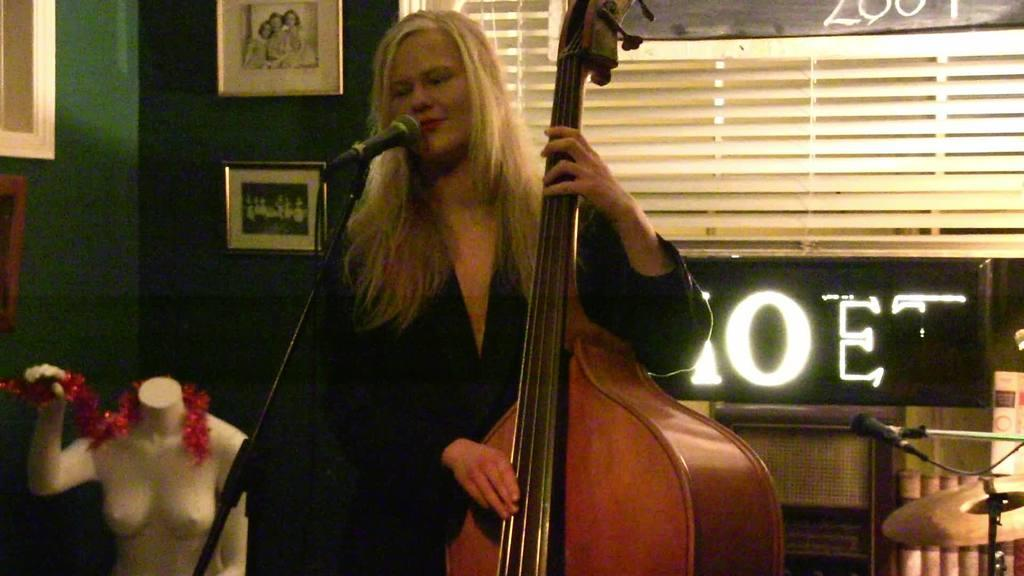Who is the main subject in the image? There is a woman in the image. What is the woman doing in the image? The woman is standing and holding a tabla in her hands. What equipment is present for amplifying sound in the image? There is a microphone and a microphone stand in the image. What can be seen on the wall in the image? There are photo frames on the wall. What type of dirt can be seen on the floor in the image? There is no dirt visible on the floor in the image. How are the plants being cared for in the image? There are no plants present in the image. 